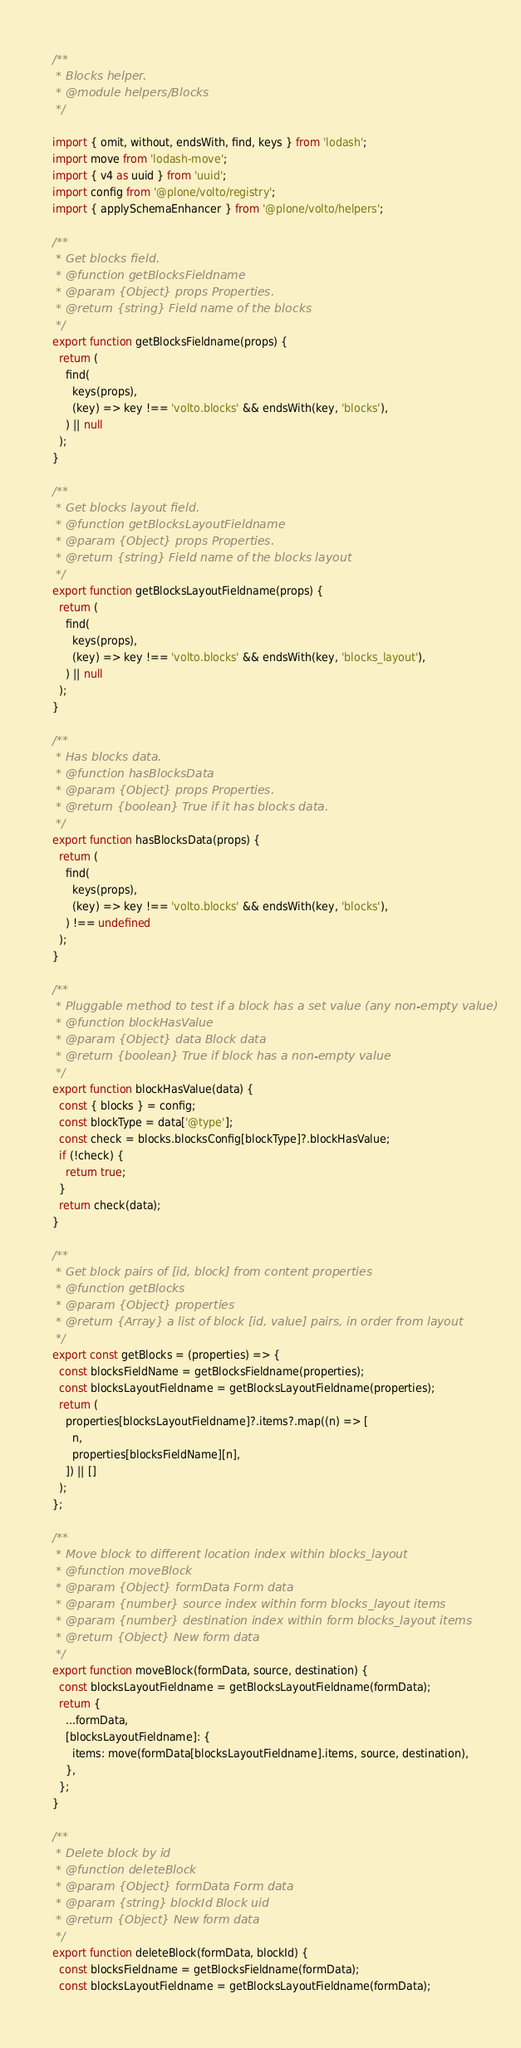Convert code to text. <code><loc_0><loc_0><loc_500><loc_500><_JavaScript_>/**
 * Blocks helper.
 * @module helpers/Blocks
 */

import { omit, without, endsWith, find, keys } from 'lodash';
import move from 'lodash-move';
import { v4 as uuid } from 'uuid';
import config from '@plone/volto/registry';
import { applySchemaEnhancer } from '@plone/volto/helpers';

/**
 * Get blocks field.
 * @function getBlocksFieldname
 * @param {Object} props Properties.
 * @return {string} Field name of the blocks
 */
export function getBlocksFieldname(props) {
  return (
    find(
      keys(props),
      (key) => key !== 'volto.blocks' && endsWith(key, 'blocks'),
    ) || null
  );
}

/**
 * Get blocks layout field.
 * @function getBlocksLayoutFieldname
 * @param {Object} props Properties.
 * @return {string} Field name of the blocks layout
 */
export function getBlocksLayoutFieldname(props) {
  return (
    find(
      keys(props),
      (key) => key !== 'volto.blocks' && endsWith(key, 'blocks_layout'),
    ) || null
  );
}

/**
 * Has blocks data.
 * @function hasBlocksData
 * @param {Object} props Properties.
 * @return {boolean} True if it has blocks data.
 */
export function hasBlocksData(props) {
  return (
    find(
      keys(props),
      (key) => key !== 'volto.blocks' && endsWith(key, 'blocks'),
    ) !== undefined
  );
}

/**
 * Pluggable method to test if a block has a set value (any non-empty value)
 * @function blockHasValue
 * @param {Object} data Block data
 * @return {boolean} True if block has a non-empty value
 */
export function blockHasValue(data) {
  const { blocks } = config;
  const blockType = data['@type'];
  const check = blocks.blocksConfig[blockType]?.blockHasValue;
  if (!check) {
    return true;
  }
  return check(data);
}

/**
 * Get block pairs of [id, block] from content properties
 * @function getBlocks
 * @param {Object} properties
 * @return {Array} a list of block [id, value] pairs, in order from layout
 */
export const getBlocks = (properties) => {
  const blocksFieldName = getBlocksFieldname(properties);
  const blocksLayoutFieldname = getBlocksLayoutFieldname(properties);
  return (
    properties[blocksLayoutFieldname]?.items?.map((n) => [
      n,
      properties[blocksFieldName][n],
    ]) || []
  );
};

/**
 * Move block to different location index within blocks_layout
 * @function moveBlock
 * @param {Object} formData Form data
 * @param {number} source index within form blocks_layout items
 * @param {number} destination index within form blocks_layout items
 * @return {Object} New form data
 */
export function moveBlock(formData, source, destination) {
  const blocksLayoutFieldname = getBlocksLayoutFieldname(formData);
  return {
    ...formData,
    [blocksLayoutFieldname]: {
      items: move(formData[blocksLayoutFieldname].items, source, destination),
    },
  };
}

/**
 * Delete block by id
 * @function deleteBlock
 * @param {Object} formData Form data
 * @param {string} blockId Block uid
 * @return {Object} New form data
 */
export function deleteBlock(formData, blockId) {
  const blocksFieldname = getBlocksFieldname(formData);
  const blocksLayoutFieldname = getBlocksLayoutFieldname(formData);
</code> 